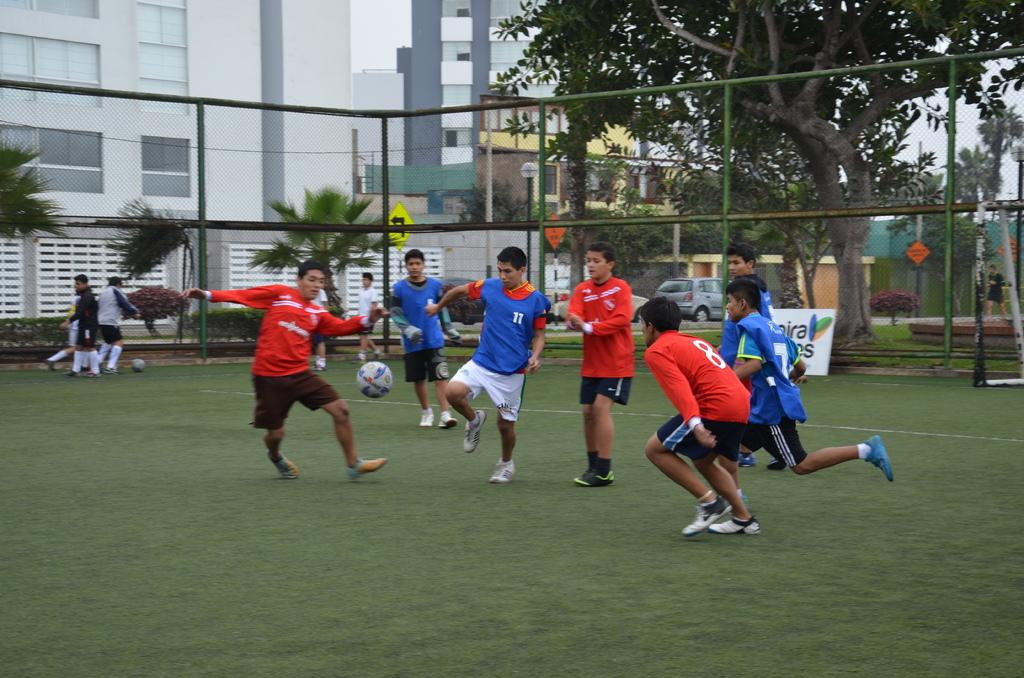How many people are in the group visible in the image? There is a group of people in the image, but the exact number is not specified. What is on the advertisement board in the image? The content of the advertisement board is not mentioned in the facts. What type of balls are on the ground in the image? The facts do not specify the type of balls on the ground. What can be seen in the background of the image? In the background of the image, there are buildings, trees, vehicles, the sky, and some unspecified objects. What type of fruit is being used to drive the vehicle in the image? There is no fruit or vehicle present in the image, so this question cannot be answered. 